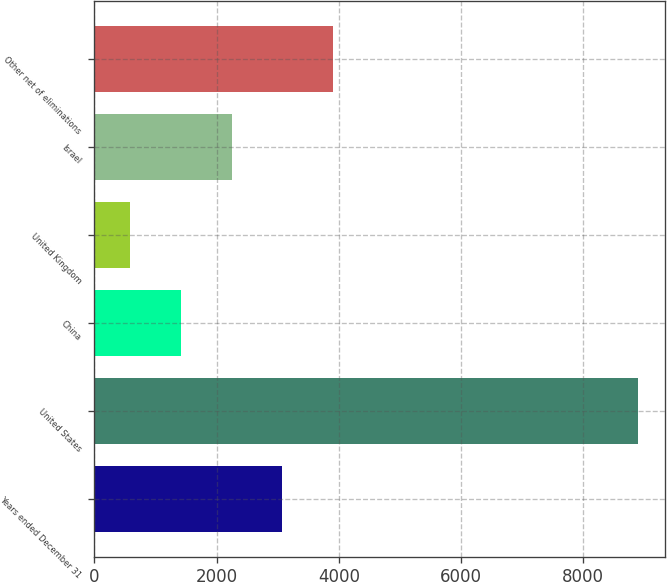<chart> <loc_0><loc_0><loc_500><loc_500><bar_chart><fcel>Years ended December 31<fcel>United States<fcel>China<fcel>United Kingdom<fcel>Israel<fcel>Other net of eliminations<nl><fcel>3075.2<fcel>8888<fcel>1414.4<fcel>584<fcel>2244.8<fcel>3905.6<nl></chart> 